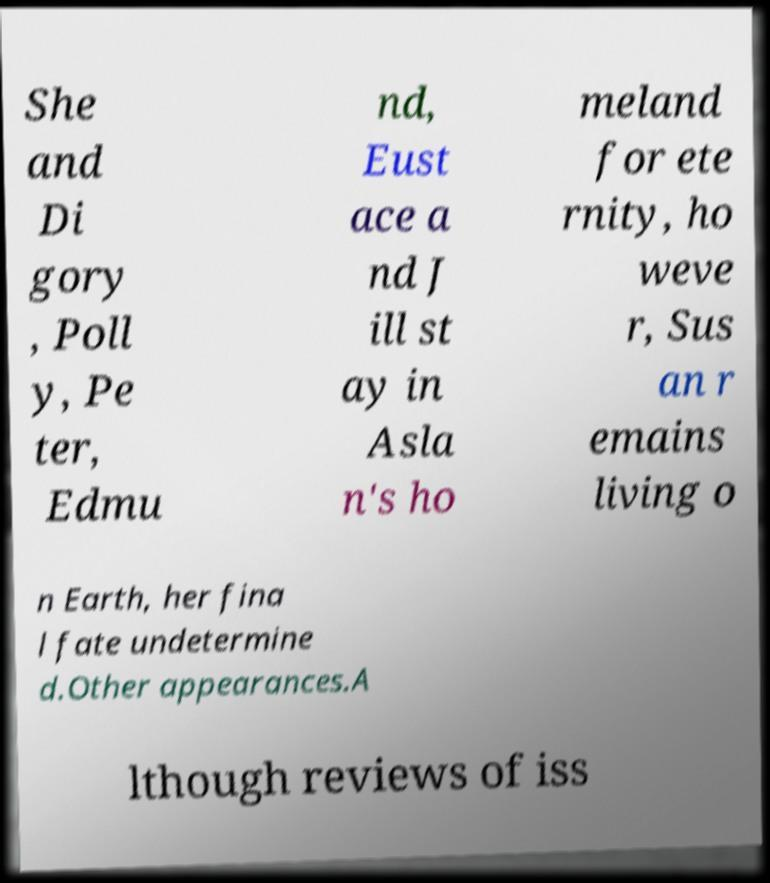Could you assist in decoding the text presented in this image and type it out clearly? She and Di gory , Poll y, Pe ter, Edmu nd, Eust ace a nd J ill st ay in Asla n's ho meland for ete rnity, ho weve r, Sus an r emains living o n Earth, her fina l fate undetermine d.Other appearances.A lthough reviews of iss 